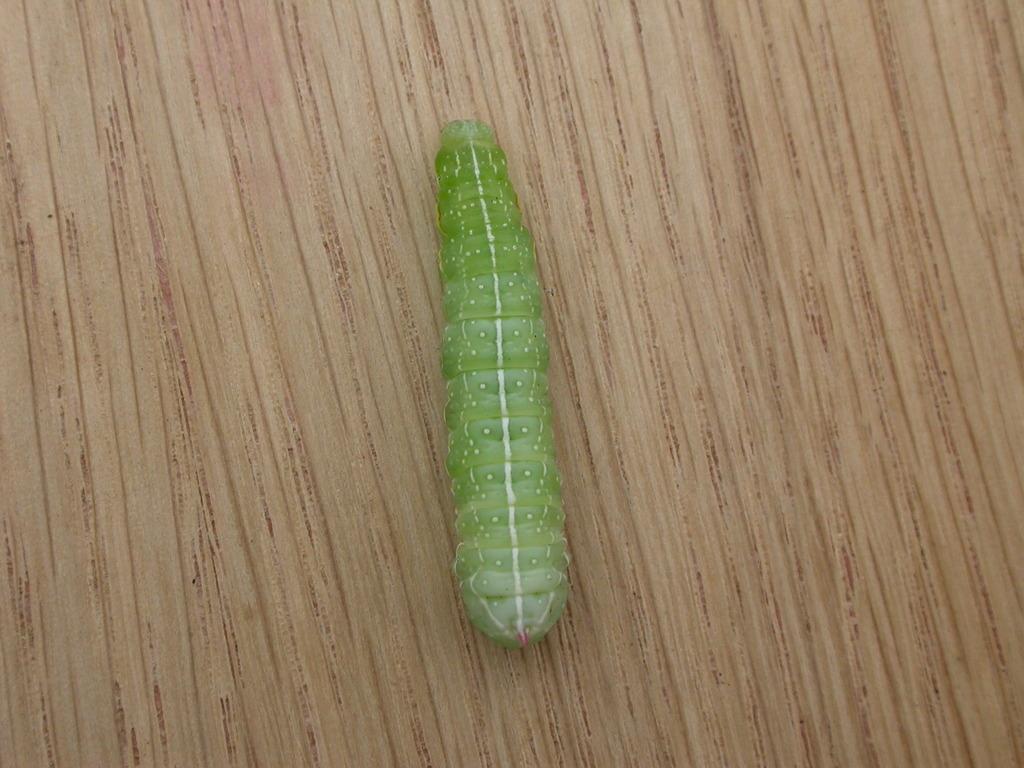How would you summarize this image in a sentence or two? In this picture I can see a caterpillar on the wood. 